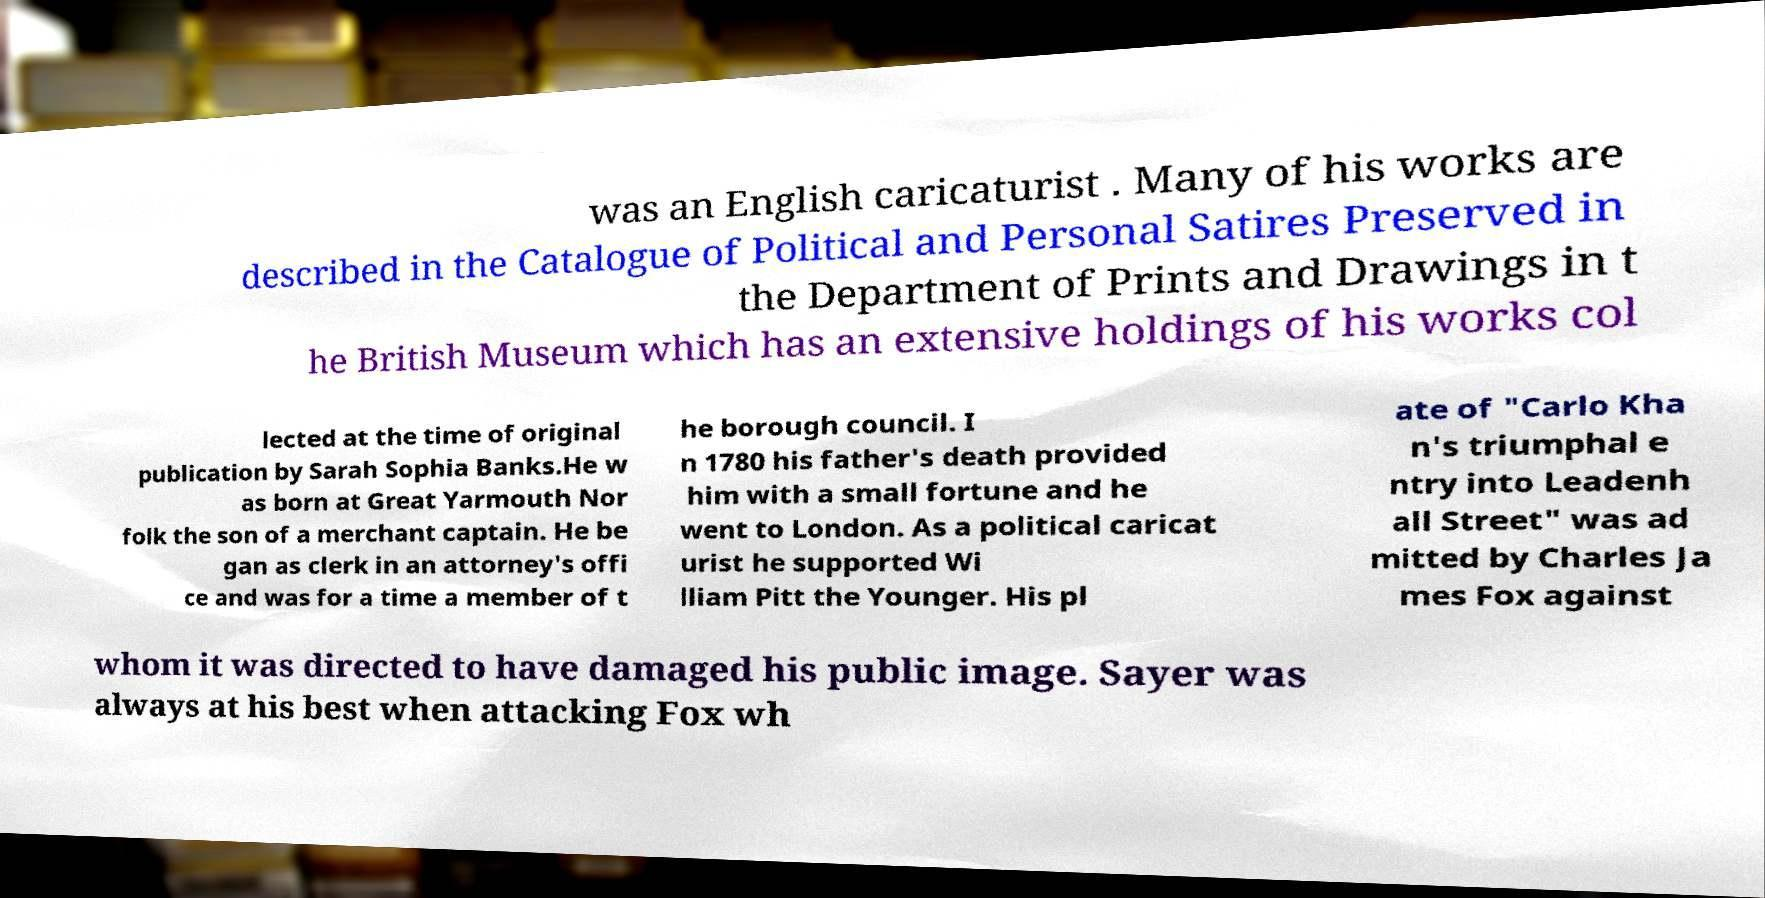I need the written content from this picture converted into text. Can you do that? was an English caricaturist . Many of his works are described in the Catalogue of Political and Personal Satires Preserved in the Department of Prints and Drawings in t he British Museum which has an extensive holdings of his works col lected at the time of original publication by Sarah Sophia Banks.He w as born at Great Yarmouth Nor folk the son of a merchant captain. He be gan as clerk in an attorney's offi ce and was for a time a member of t he borough council. I n 1780 his father's death provided him with a small fortune and he went to London. As a political caricat urist he supported Wi lliam Pitt the Younger. His pl ate of "Carlo Kha n's triumphal e ntry into Leadenh all Street" was ad mitted by Charles Ja mes Fox against whom it was directed to have damaged his public image. Sayer was always at his best when attacking Fox wh 